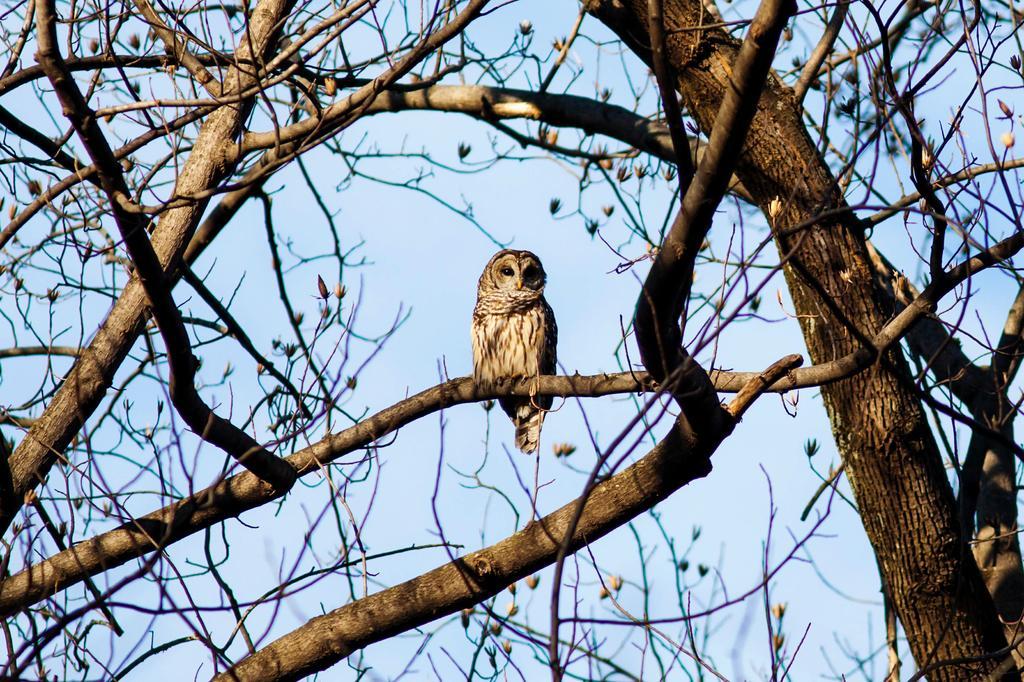How would you summarize this image in a sentence or two? In this image we can see one owl on a big tree with flowers and at the top there is the sky. 